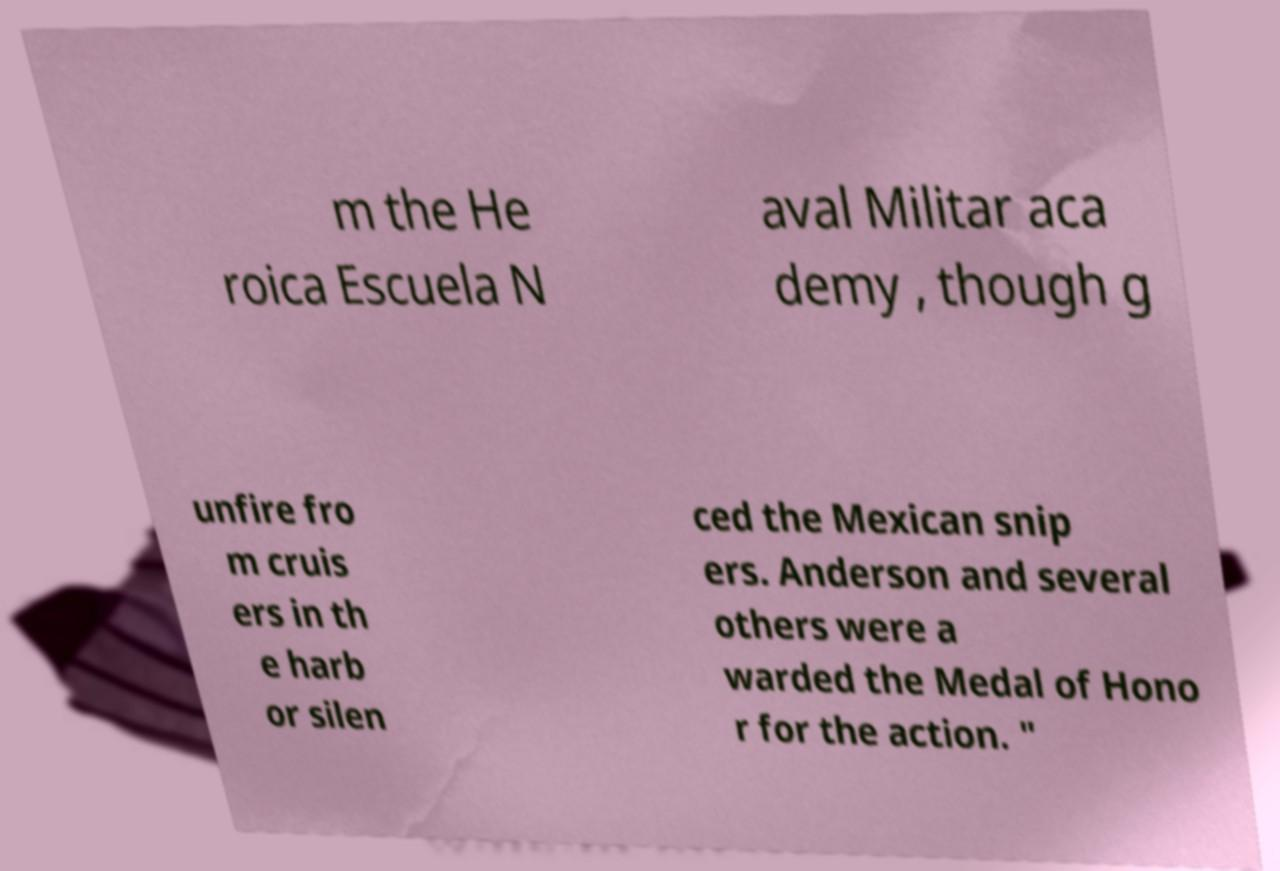There's text embedded in this image that I need extracted. Can you transcribe it verbatim? m the He roica Escuela N aval Militar aca demy , though g unfire fro m cruis ers in th e harb or silen ced the Mexican snip ers. Anderson and several others were a warded the Medal of Hono r for the action. " 